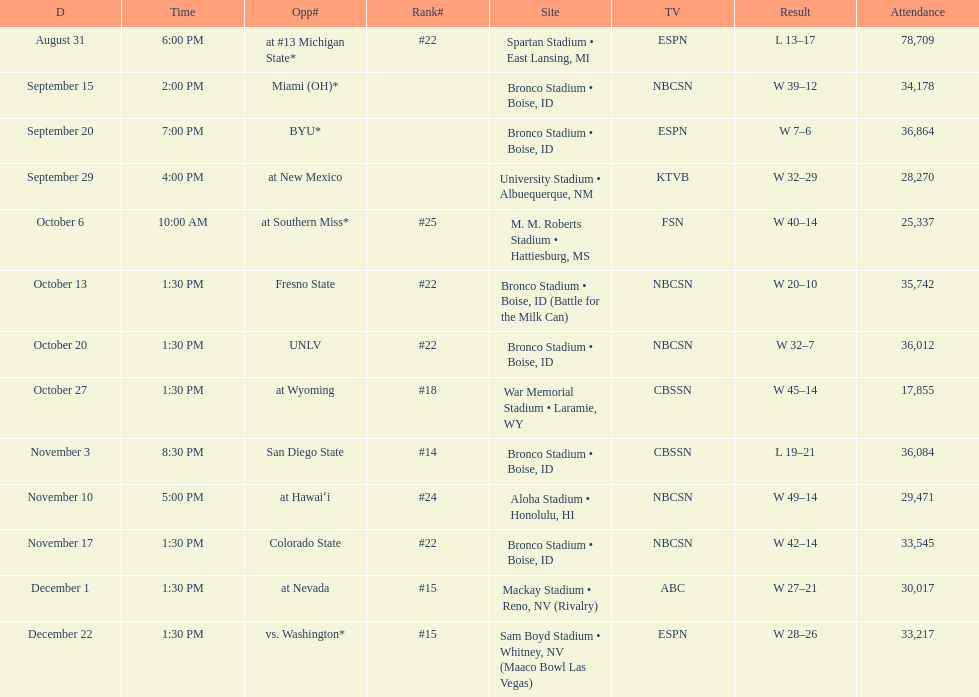Did the broncos on september 29th win by less than 5 points? Yes. 